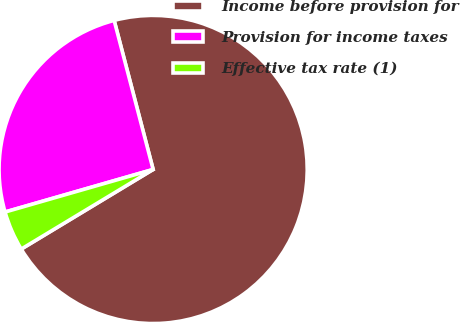<chart> <loc_0><loc_0><loc_500><loc_500><pie_chart><fcel>Income before provision for<fcel>Provision for income taxes<fcel>Effective tax rate (1)<nl><fcel>70.43%<fcel>25.38%<fcel>4.19%<nl></chart> 